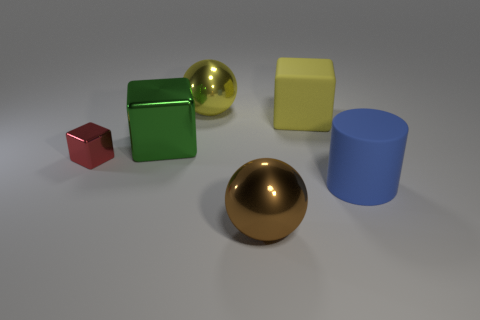There is a rubber thing that is in front of the small cube; is it the same shape as the rubber thing that is behind the blue cylinder?
Provide a succinct answer. No. The blue cylinder is what size?
Your answer should be very brief. Large. There is a cube behind the green metallic block that is left of the large metallic object that is in front of the blue object; what is it made of?
Keep it short and to the point. Rubber. What number of other objects are the same color as the big cylinder?
Provide a short and direct response. 0. How many gray things are either matte cylinders or metallic things?
Keep it short and to the point. 0. What material is the big blue cylinder that is in front of the yellow cube?
Provide a short and direct response. Rubber. Is the block to the right of the yellow metal sphere made of the same material as the big blue object?
Ensure brevity in your answer.  Yes. What is the shape of the yellow shiny thing?
Give a very brief answer. Sphere. How many large yellow metal things are left of the cube on the right side of the large shiny object that is in front of the green metal object?
Provide a short and direct response. 1. How many other things are the same material as the big yellow ball?
Make the answer very short. 3. 